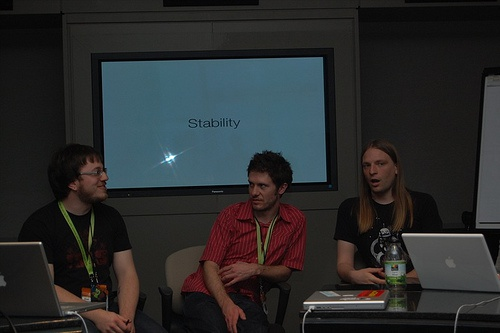Describe the objects in this image and their specific colors. I can see tv in black, teal, and maroon tones, people in black, maroon, and gray tones, people in black, maroon, brown, and gray tones, people in black, maroon, brown, and gray tones, and laptop in black, gray, darkgray, and lightgray tones in this image. 